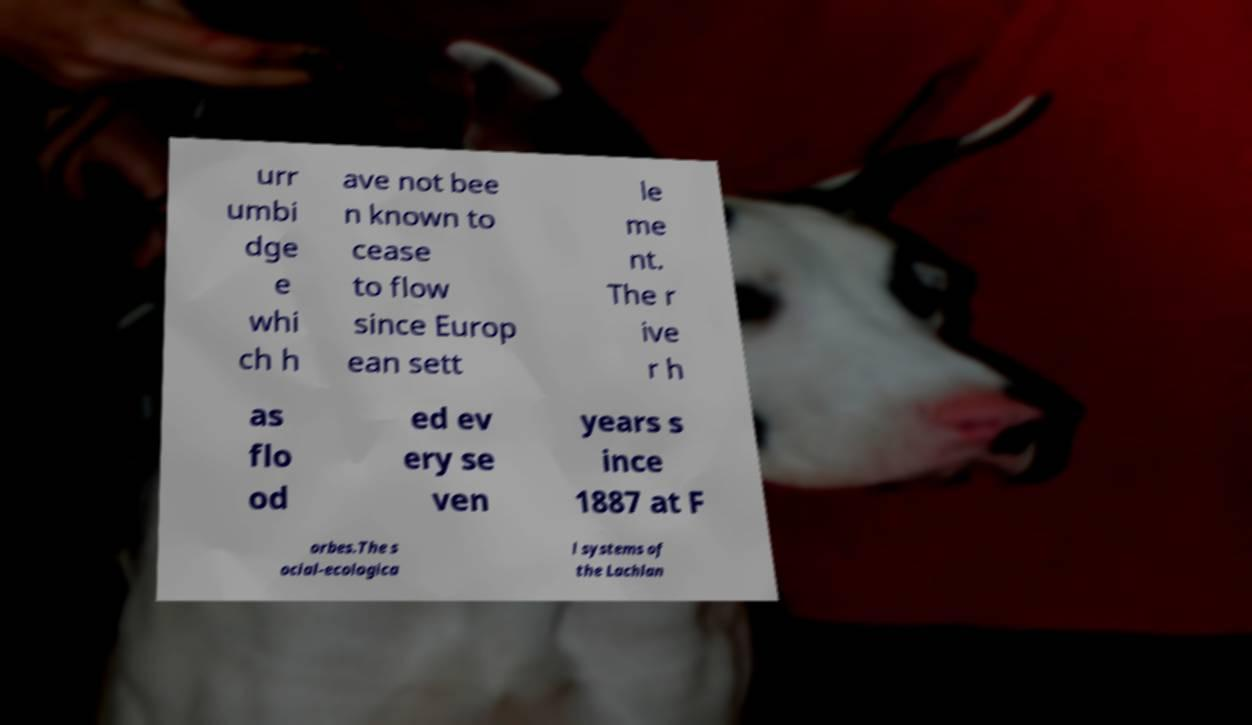I need the written content from this picture converted into text. Can you do that? urr umbi dge e whi ch h ave not bee n known to cease to flow since Europ ean sett le me nt. The r ive r h as flo od ed ev ery se ven years s ince 1887 at F orbes.The s ocial-ecologica l systems of the Lachlan 